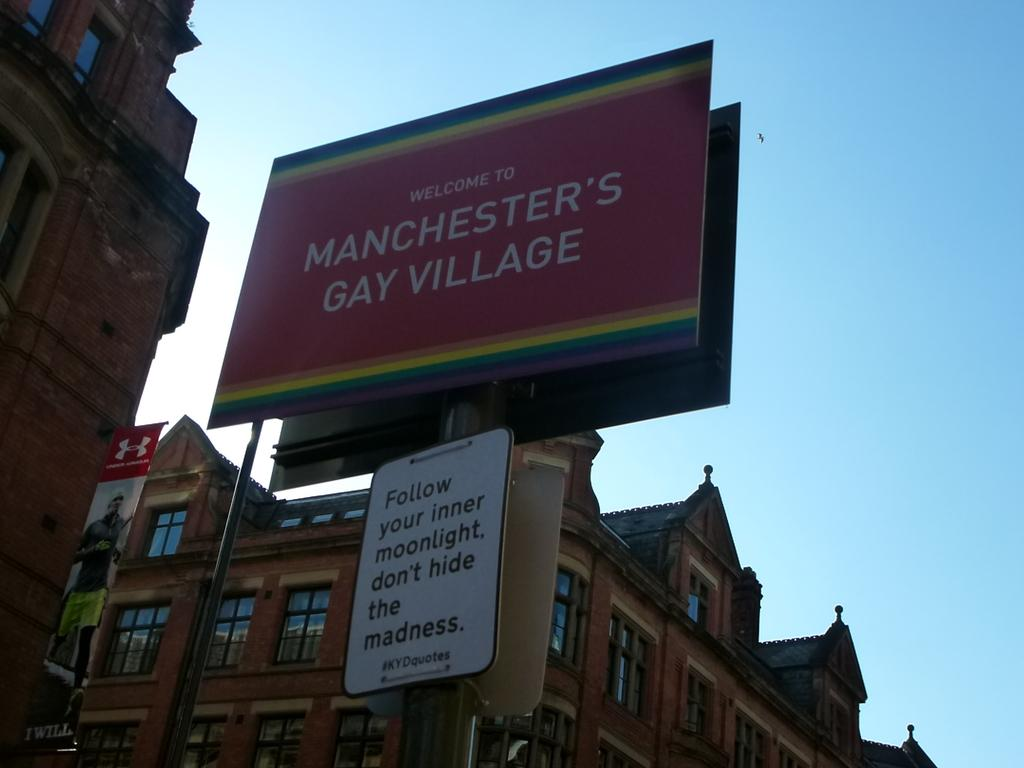<image>
Relay a brief, clear account of the picture shown. The city has a gay area in this neighborhood called Manchester's Gay Village. 